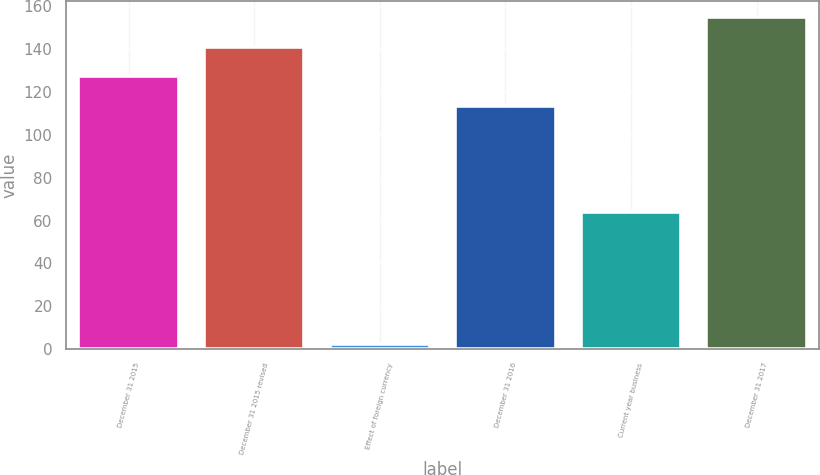Convert chart to OTSL. <chart><loc_0><loc_0><loc_500><loc_500><bar_chart><fcel>December 31 2015<fcel>December 31 2015 revised<fcel>Effect of foreign currency<fcel>December 31 2016<fcel>Current year business<fcel>December 31 2017<nl><fcel>127.43<fcel>141.16<fcel>2.1<fcel>113.7<fcel>63.9<fcel>154.89<nl></chart> 